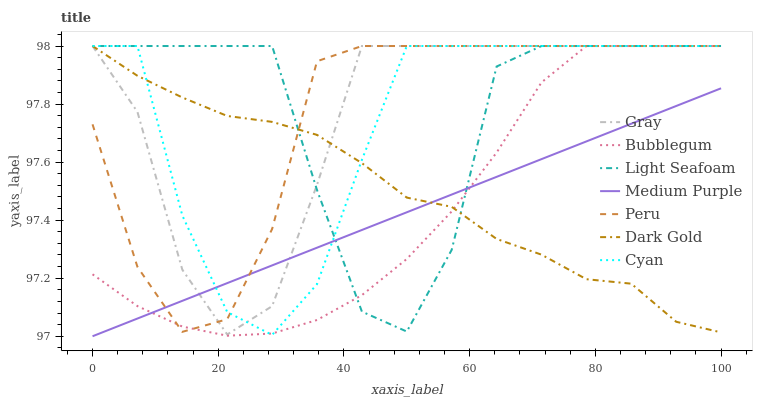Does Medium Purple have the minimum area under the curve?
Answer yes or no. Yes. Does Light Seafoam have the maximum area under the curve?
Answer yes or no. Yes. Does Dark Gold have the minimum area under the curve?
Answer yes or no. No. Does Dark Gold have the maximum area under the curve?
Answer yes or no. No. Is Medium Purple the smoothest?
Answer yes or no. Yes. Is Light Seafoam the roughest?
Answer yes or no. Yes. Is Dark Gold the smoothest?
Answer yes or no. No. Is Dark Gold the roughest?
Answer yes or no. No. Does Medium Purple have the lowest value?
Answer yes or no. Yes. Does Dark Gold have the lowest value?
Answer yes or no. No. Does Light Seafoam have the highest value?
Answer yes or no. Yes. Does Medium Purple have the highest value?
Answer yes or no. No. Does Cyan intersect Medium Purple?
Answer yes or no. Yes. Is Cyan less than Medium Purple?
Answer yes or no. No. Is Cyan greater than Medium Purple?
Answer yes or no. No. 